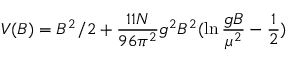<formula> <loc_0><loc_0><loc_500><loc_500>V ( B ) = B ^ { 2 } / 2 + \frac { 1 1 N } { 9 6 \pi ^ { 2 } } g ^ { 2 } B ^ { 2 } ( \ln \frac { g B } { \mu ^ { 2 } } - \frac { 1 } { 2 } )</formula> 